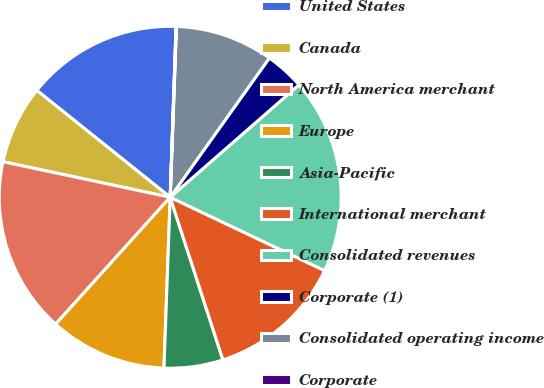Convert chart. <chart><loc_0><loc_0><loc_500><loc_500><pie_chart><fcel>United States<fcel>Canada<fcel>North America merchant<fcel>Europe<fcel>Asia-Pacific<fcel>International merchant<fcel>Consolidated revenues<fcel>Corporate (1)<fcel>Consolidated operating income<fcel>Corporate<nl><fcel>14.79%<fcel>7.42%<fcel>16.64%<fcel>11.11%<fcel>5.57%<fcel>12.95%<fcel>18.48%<fcel>3.73%<fcel>9.26%<fcel>0.04%<nl></chart> 